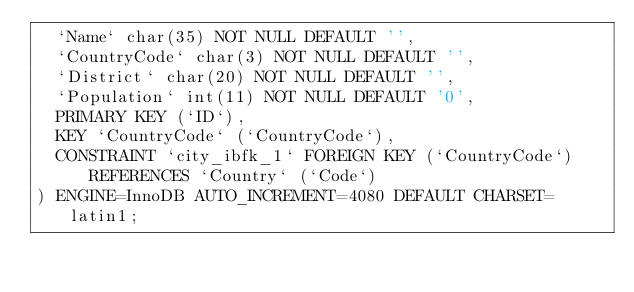<code> <loc_0><loc_0><loc_500><loc_500><_SQL_>  `Name` char(35) NOT NULL DEFAULT '',
  `CountryCode` char(3) NOT NULL DEFAULT '',
  `District` char(20) NOT NULL DEFAULT '',
  `Population` int(11) NOT NULL DEFAULT '0',
  PRIMARY KEY (`ID`),
  KEY `CountryCode` (`CountryCode`),
  CONSTRAINT `city_ibfk_1` FOREIGN KEY (`CountryCode`) REFERENCES `Country` (`Code`)
) ENGINE=InnoDB AUTO_INCREMENT=4080 DEFAULT CHARSET=latin1;

</code> 